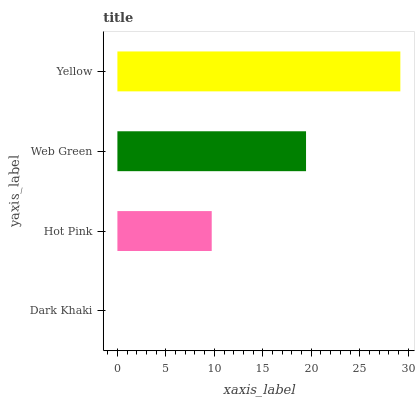Is Dark Khaki the minimum?
Answer yes or no. Yes. Is Yellow the maximum?
Answer yes or no. Yes. Is Hot Pink the minimum?
Answer yes or no. No. Is Hot Pink the maximum?
Answer yes or no. No. Is Hot Pink greater than Dark Khaki?
Answer yes or no. Yes. Is Dark Khaki less than Hot Pink?
Answer yes or no. Yes. Is Dark Khaki greater than Hot Pink?
Answer yes or no. No. Is Hot Pink less than Dark Khaki?
Answer yes or no. No. Is Web Green the high median?
Answer yes or no. Yes. Is Hot Pink the low median?
Answer yes or no. Yes. Is Hot Pink the high median?
Answer yes or no. No. Is Web Green the low median?
Answer yes or no. No. 